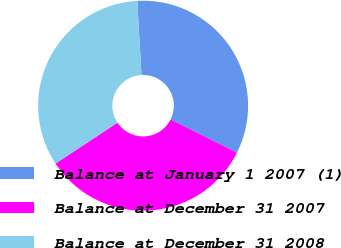<chart> <loc_0><loc_0><loc_500><loc_500><pie_chart><fcel>Balance at January 1 2007 (1)<fcel>Balance at December 31 2007<fcel>Balance at December 31 2008<nl><fcel>33.26%<fcel>33.33%<fcel>33.41%<nl></chart> 